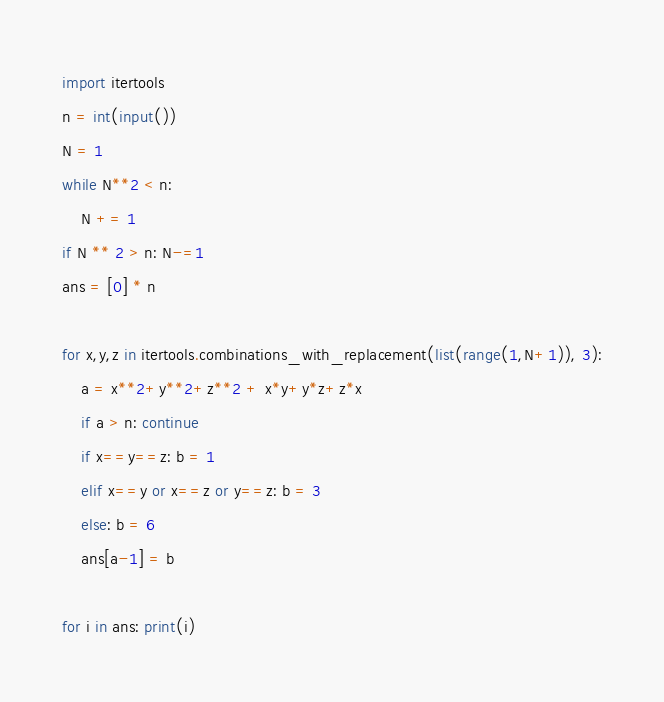Convert code to text. <code><loc_0><loc_0><loc_500><loc_500><_Python_>import itertools
n = int(input())
N = 1
while N**2 < n:
    N += 1
if N ** 2 > n: N-=1
ans = [0] * n

for x,y,z in itertools.combinations_with_replacement(list(range(1,N+1)), 3):
    a = x**2+y**2+z**2 + x*y+y*z+z*x
    if a > n: continue
    if x==y==z: b = 1
    elif x==y or x==z or y==z: b = 3
    else: b = 6
    ans[a-1] = b

for i in ans: print(i)</code> 